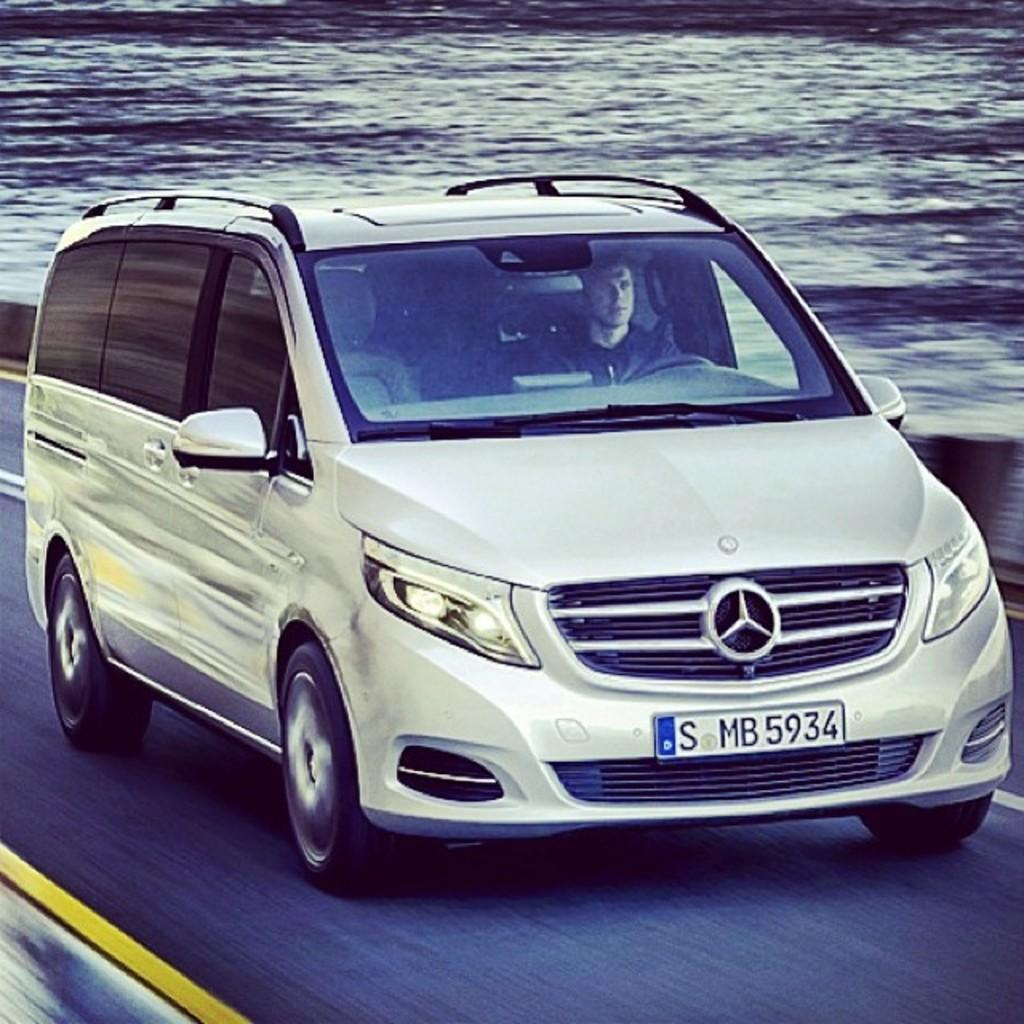<image>
Present a compact description of the photo's key features. Mercedes Benz Car that has license plate SMB 5934. 